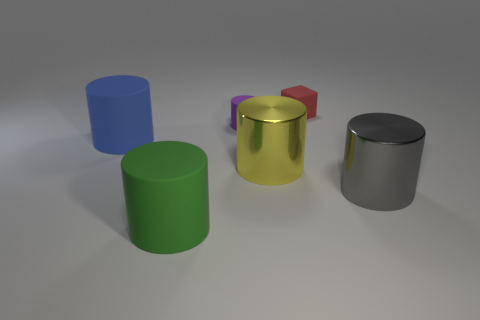Subtract all small matte cylinders. How many cylinders are left? 4 Subtract 2 cylinders. How many cylinders are left? 3 Subtract all gray cylinders. How many cylinders are left? 4 Add 2 red rubber blocks. How many objects exist? 8 Subtract all yellow cylinders. Subtract all cyan cubes. How many cylinders are left? 4 Subtract all cylinders. How many objects are left? 1 Add 1 small purple rubber objects. How many small purple rubber objects exist? 2 Subtract 0 cyan cubes. How many objects are left? 6 Subtract all large gray metal things. Subtract all small purple rubber blocks. How many objects are left? 5 Add 6 tiny red things. How many tiny red things are left? 7 